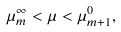Convert formula to latex. <formula><loc_0><loc_0><loc_500><loc_500>\mu _ { m } ^ { \infty } < \mu < \mu _ { m + 1 } ^ { 0 } ,</formula> 